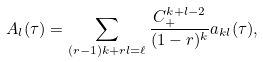<formula> <loc_0><loc_0><loc_500><loc_500>A _ { l } ( \tau ) = \sum _ { ( r - 1 ) k + r l = \ell } \frac { C _ { + } ^ { k + l - 2 } } { ( 1 - r ) ^ { k } } a _ { k l } ( \tau ) ,</formula> 